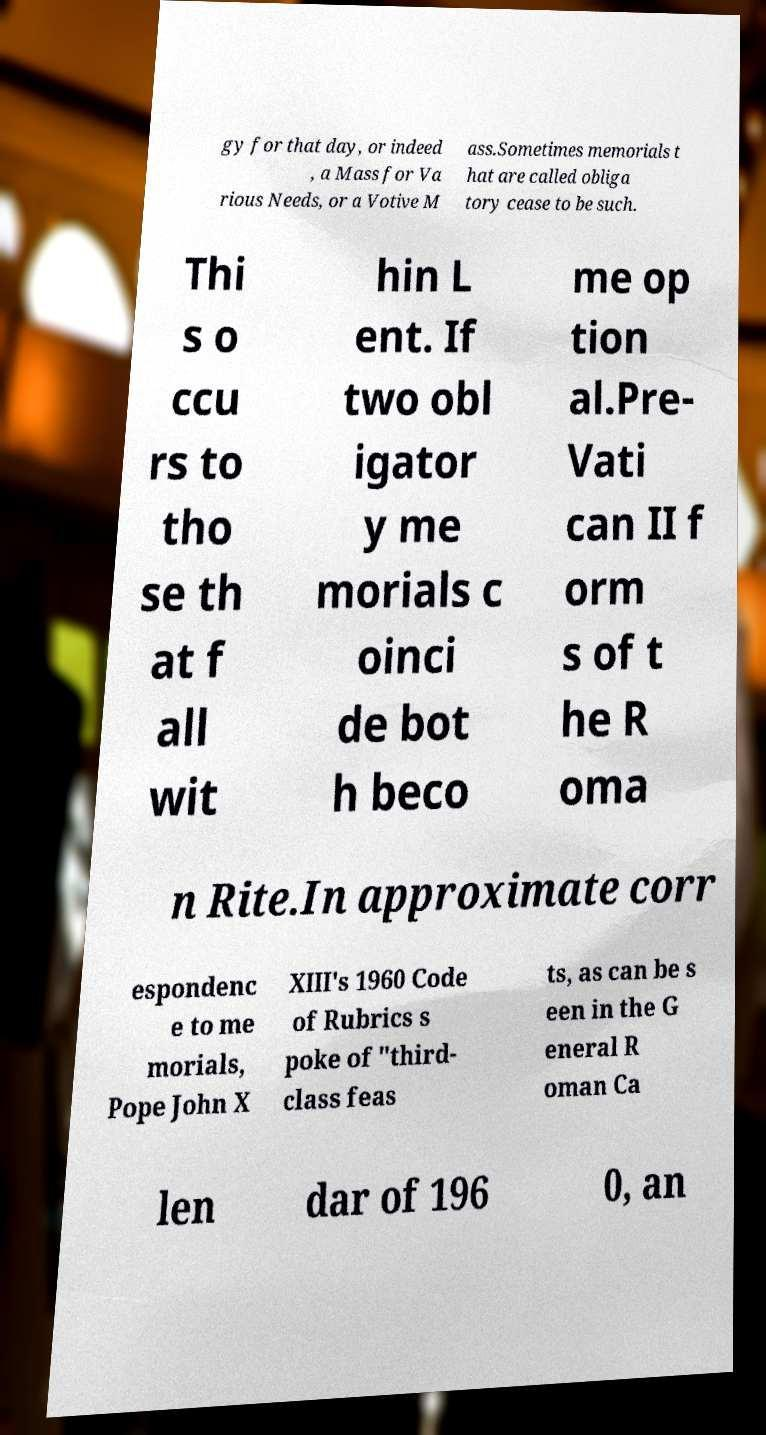Can you accurately transcribe the text from the provided image for me? gy for that day, or indeed , a Mass for Va rious Needs, or a Votive M ass.Sometimes memorials t hat are called obliga tory cease to be such. Thi s o ccu rs to tho se th at f all wit hin L ent. If two obl igator y me morials c oinci de bot h beco me op tion al.Pre- Vati can II f orm s of t he R oma n Rite.In approximate corr espondenc e to me morials, Pope John X XIII's 1960 Code of Rubrics s poke of "third- class feas ts, as can be s een in the G eneral R oman Ca len dar of 196 0, an 